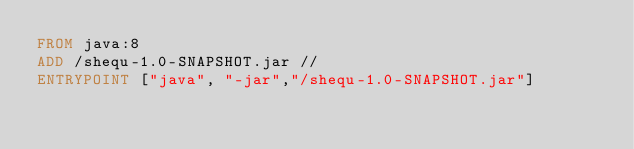<code> <loc_0><loc_0><loc_500><loc_500><_Dockerfile_>FROM java:8
ADD /shequ-1.0-SNAPSHOT.jar //
ENTRYPOINT ["java", "-jar","/shequ-1.0-SNAPSHOT.jar"]
</code> 